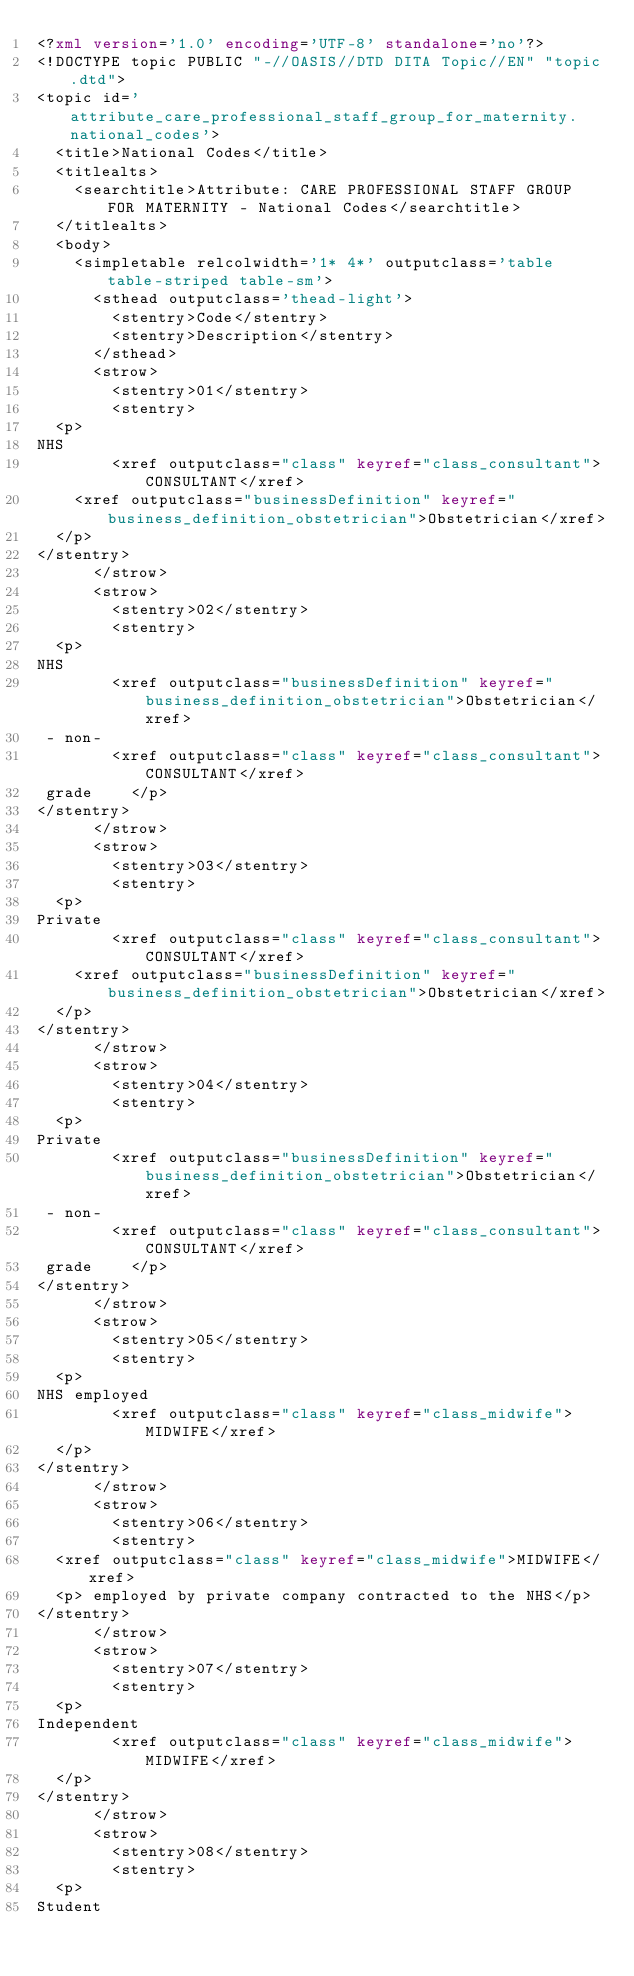Convert code to text. <code><loc_0><loc_0><loc_500><loc_500><_XML_><?xml version='1.0' encoding='UTF-8' standalone='no'?>
<!DOCTYPE topic PUBLIC "-//OASIS//DTD DITA Topic//EN" "topic.dtd">
<topic id='attribute_care_professional_staff_group_for_maternity.national_codes'>
  <title>National Codes</title>
  <titlealts>
    <searchtitle>Attribute: CARE PROFESSIONAL STAFF GROUP FOR MATERNITY - National Codes</searchtitle>
  </titlealts>
  <body>
    <simpletable relcolwidth='1* 4*' outputclass='table table-striped table-sm'>
      <sthead outputclass='thead-light'>
        <stentry>Code</stentry>
        <stentry>Description</stentry>
      </sthead>
      <strow>
        <stentry>01</stentry>
        <stentry>
  <p>
NHS 
        <xref outputclass="class" keyref="class_consultant">CONSULTANT</xref>
    <xref outputclass="businessDefinition" keyref="business_definition_obstetrician">Obstetrician</xref>
  </p>
</stentry>
      </strow>
      <strow>
        <stentry>02</stentry>
        <stentry>
  <p>
NHS 
        <xref outputclass="businessDefinition" keyref="business_definition_obstetrician">Obstetrician</xref>
 - non-
        <xref outputclass="class" keyref="class_consultant">CONSULTANT</xref>
 grade    </p>
</stentry>
      </strow>
      <strow>
        <stentry>03</stentry>
        <stentry>
  <p>
Private 
        <xref outputclass="class" keyref="class_consultant">CONSULTANT</xref>
    <xref outputclass="businessDefinition" keyref="business_definition_obstetrician">Obstetrician</xref>
  </p>
</stentry>
      </strow>
      <strow>
        <stentry>04</stentry>
        <stentry>
  <p>
Private 
        <xref outputclass="businessDefinition" keyref="business_definition_obstetrician">Obstetrician</xref>
 - non-
        <xref outputclass="class" keyref="class_consultant">CONSULTANT</xref>
 grade    </p>
</stentry>
      </strow>
      <strow>
        <stentry>05</stentry>
        <stentry>
  <p>
NHS employed 
        <xref outputclass="class" keyref="class_midwife">MIDWIFE</xref>
  </p>
</stentry>
      </strow>
      <strow>
        <stentry>06</stentry>
        <stentry>
  <xref outputclass="class" keyref="class_midwife">MIDWIFE</xref>
  <p> employed by private company contracted to the NHS</p>
</stentry>
      </strow>
      <strow>
        <stentry>07</stentry>
        <stentry>
  <p>
Independent 
        <xref outputclass="class" keyref="class_midwife">MIDWIFE</xref>
  </p>
</stentry>
      </strow>
      <strow>
        <stentry>08</stentry>
        <stentry>
  <p>
Student </code> 